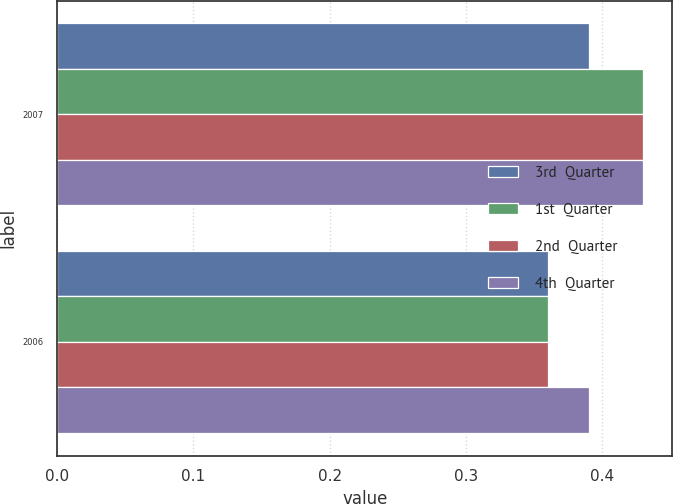<chart> <loc_0><loc_0><loc_500><loc_500><stacked_bar_chart><ecel><fcel>2007<fcel>2006<nl><fcel>3rd  Quarter<fcel>0.39<fcel>0.36<nl><fcel>1st  Quarter<fcel>0.43<fcel>0.36<nl><fcel>2nd  Quarter<fcel>0.43<fcel>0.36<nl><fcel>4th  Quarter<fcel>0.43<fcel>0.39<nl></chart> 